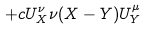Convert formula to latex. <formula><loc_0><loc_0><loc_500><loc_500>+ c U ^ { \nu } _ { X } \nu ( X - Y ) U ^ { \mu } _ { Y }</formula> 